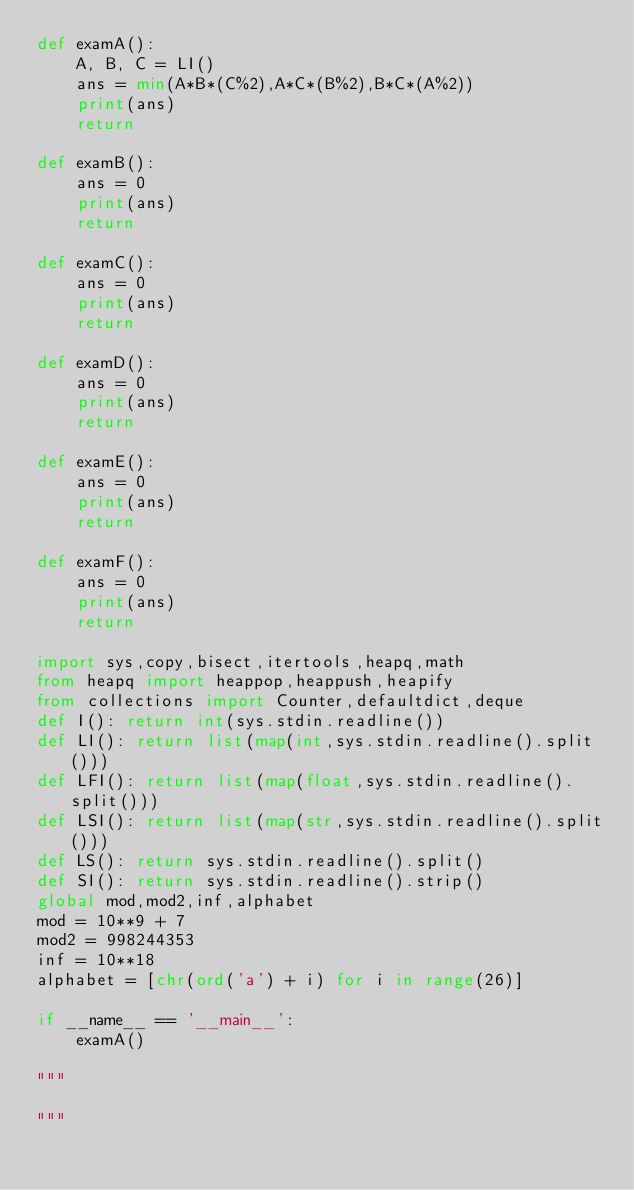<code> <loc_0><loc_0><loc_500><loc_500><_Python_>def examA():
    A, B, C = LI()
    ans = min(A*B*(C%2),A*C*(B%2),B*C*(A%2))
    print(ans)
    return

def examB():
    ans = 0
    print(ans)
    return

def examC():
    ans = 0
    print(ans)
    return

def examD():
    ans = 0
    print(ans)
    return

def examE():
    ans = 0
    print(ans)
    return

def examF():
    ans = 0
    print(ans)
    return

import sys,copy,bisect,itertools,heapq,math
from heapq import heappop,heappush,heapify
from collections import Counter,defaultdict,deque
def I(): return int(sys.stdin.readline())
def LI(): return list(map(int,sys.stdin.readline().split()))
def LFI(): return list(map(float,sys.stdin.readline().split()))
def LSI(): return list(map(str,sys.stdin.readline().split()))
def LS(): return sys.stdin.readline().split()
def SI(): return sys.stdin.readline().strip()
global mod,mod2,inf,alphabet
mod = 10**9 + 7
mod2 = 998244353
inf = 10**18
alphabet = [chr(ord('a') + i) for i in range(26)]

if __name__ == '__main__':
    examA()

"""

"""</code> 